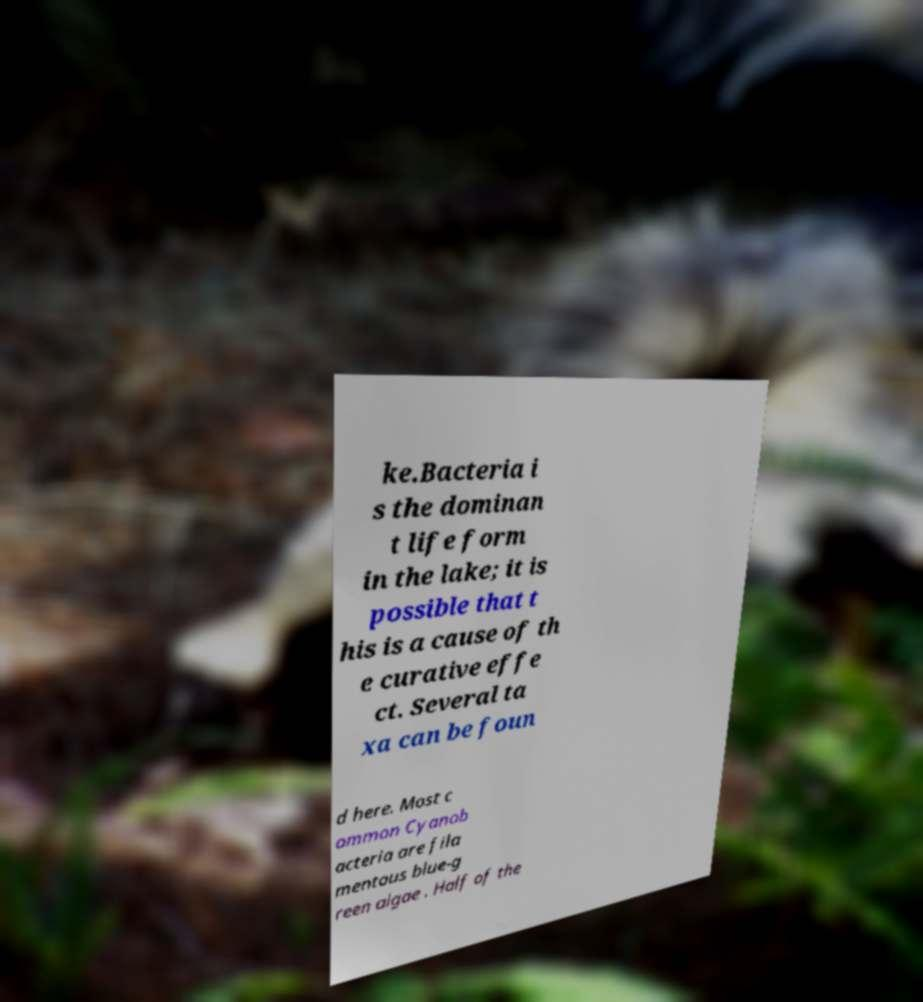Could you extract and type out the text from this image? ke.Bacteria i s the dominan t life form in the lake; it is possible that t his is a cause of th e curative effe ct. Several ta xa can be foun d here. Most c ommon Cyanob acteria are fila mentous blue-g reen algae . Half of the 